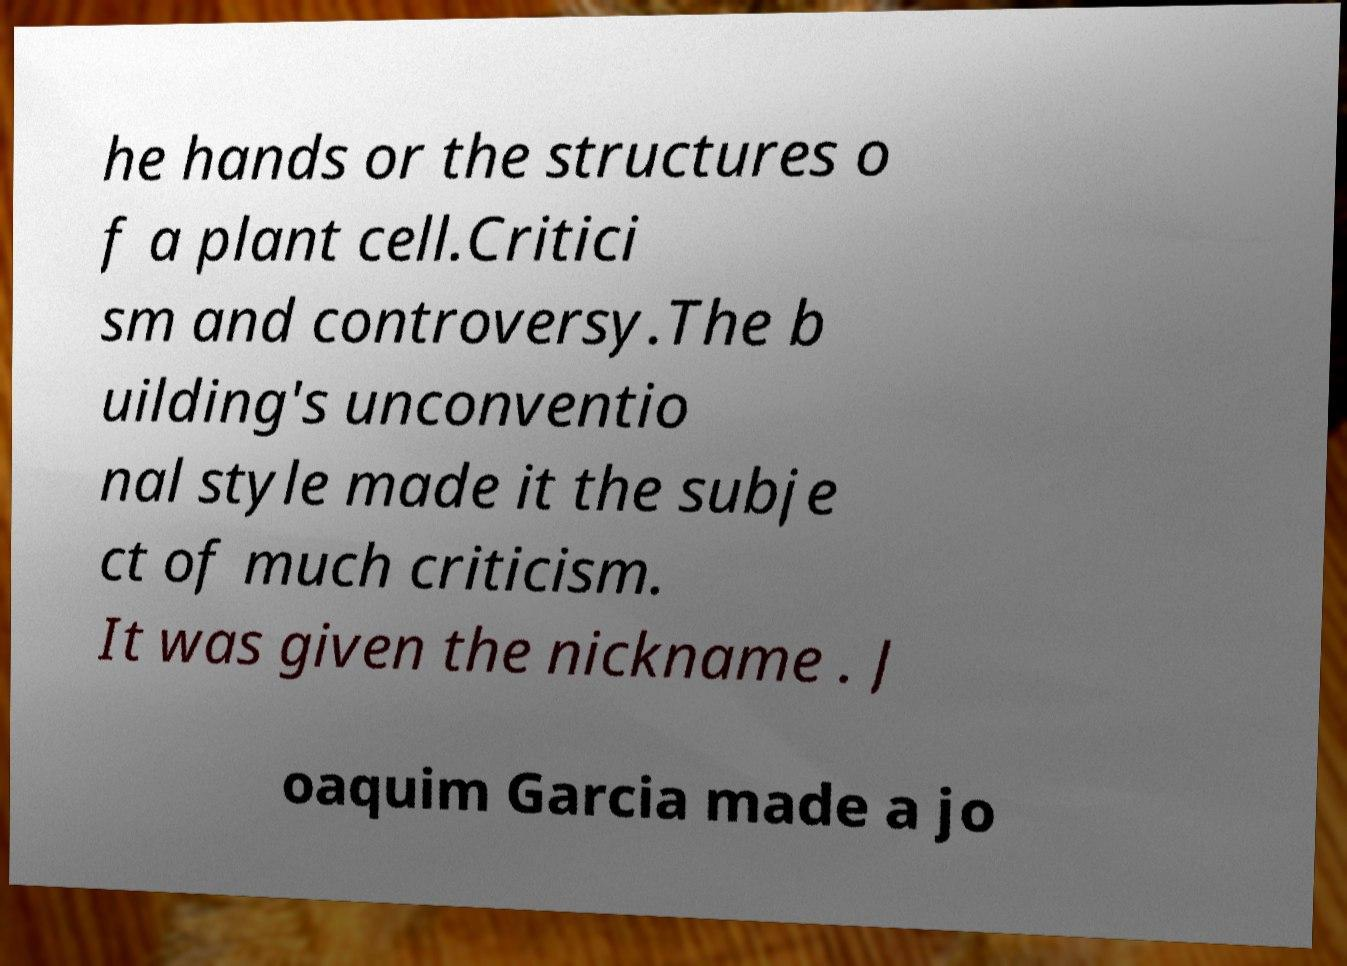Could you extract and type out the text from this image? he hands or the structures o f a plant cell.Critici sm and controversy.The b uilding's unconventio nal style made it the subje ct of much criticism. It was given the nickname . J oaquim Garcia made a jo 